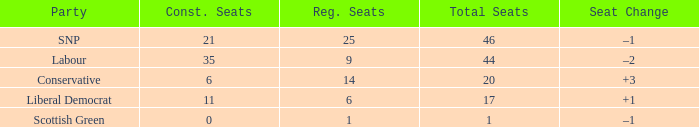How many regional seats were there with the SNP party and where the number of total seats was bigger than 46? 0.0. 